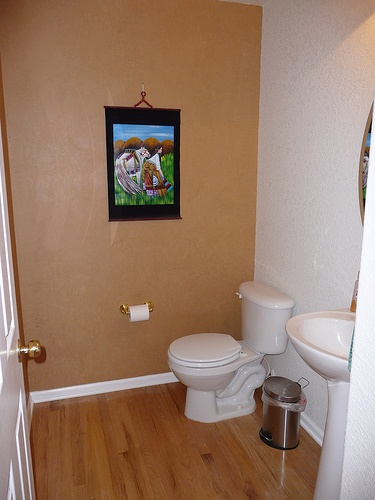Describe the objects in this image and their specific colors. I can see toilet in maroon, darkgray, and gray tones and sink in maroon, lightgray, and darkgray tones in this image. 